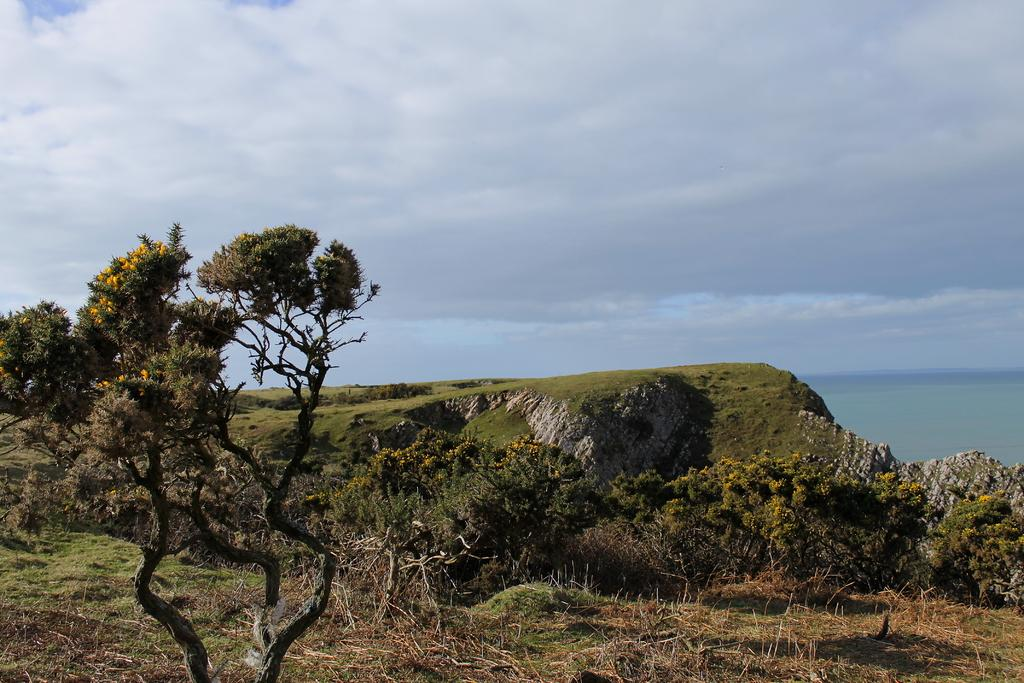What type of vegetation can be seen in the image? There is a group of trees and plants with flowers in the image. What geographical feature is present in the image? A: There is a hill in the image. What natural feature can be seen near the hill? There is a water body in the image. What is the condition of the sky in the image? The sky is visible in the image and appears cloudy. Can you see any firemen in the image? There are no firemen present in the image. Are the plants with flowers swimming in the water body? The plants with flowers are not swimming in the water body; they are growing on land near the water body. 